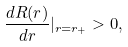Convert formula to latex. <formula><loc_0><loc_0><loc_500><loc_500>\frac { d R ( r ) } { d r } | _ { r = r _ { + } } > 0 ,</formula> 